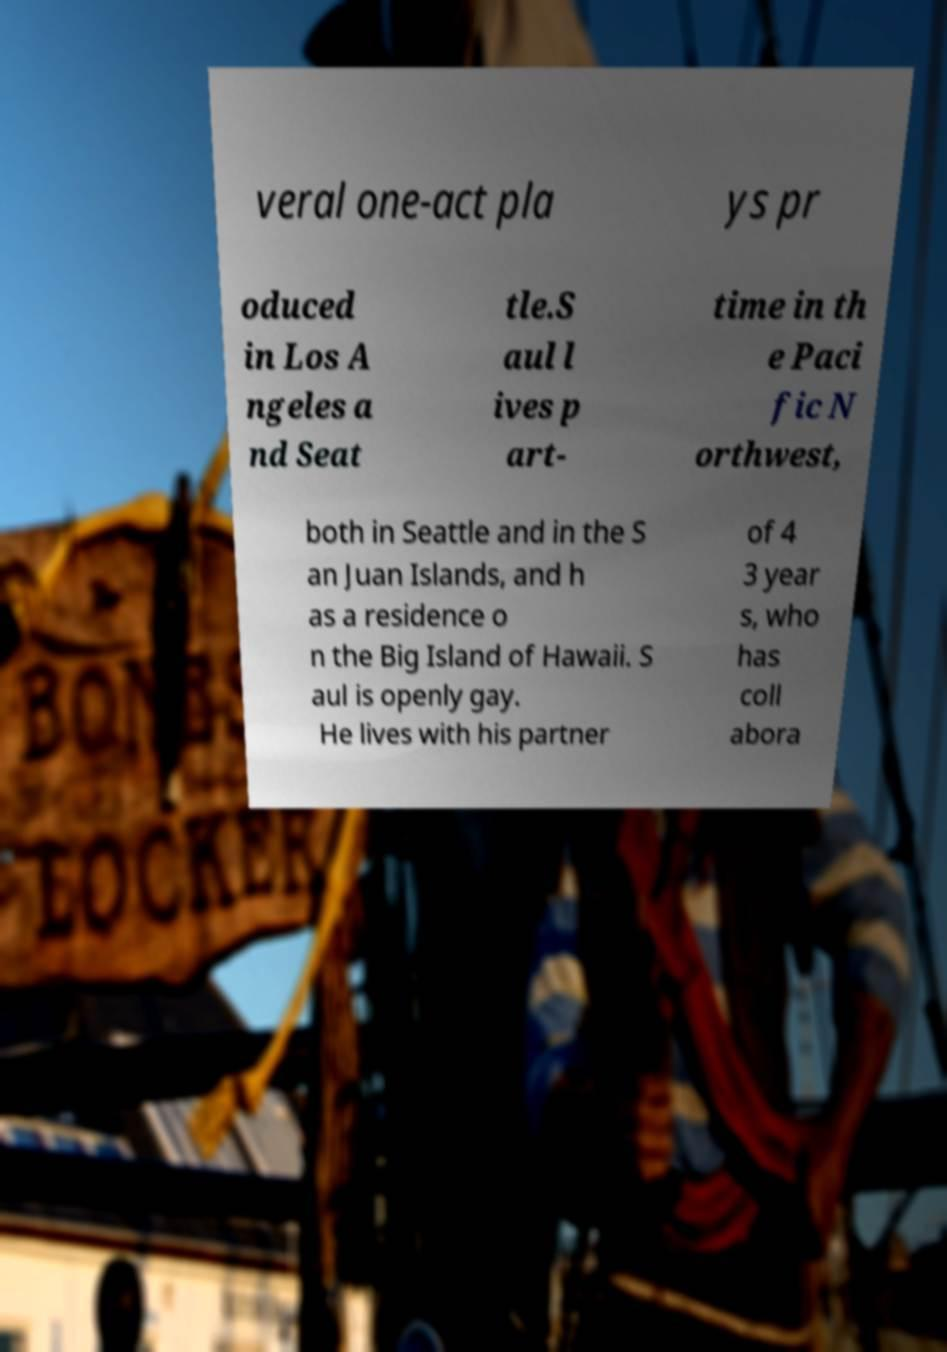Please read and relay the text visible in this image. What does it say? veral one-act pla ys pr oduced in Los A ngeles a nd Seat tle.S aul l ives p art- time in th e Paci fic N orthwest, both in Seattle and in the S an Juan Islands, and h as a residence o n the Big Island of Hawaii. S aul is openly gay. He lives with his partner of 4 3 year s, who has coll abora 